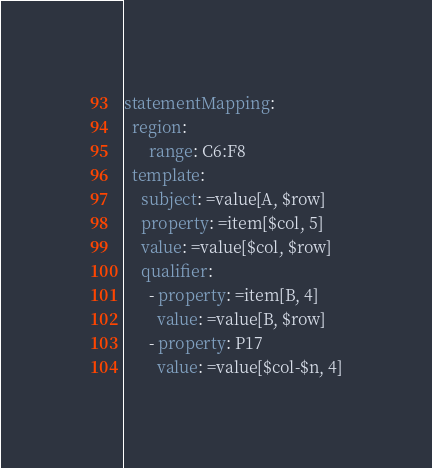<code> <loc_0><loc_0><loc_500><loc_500><_YAML_>statementMapping:
  region:
      range: C6:F8
  template:
    subject: =value[A, $row]
    property: =item[$col, 5]
    value: =value[$col, $row]
    qualifier:
      - property: =item[B, 4]
        value: =value[B, $row]
      - property: P17
        value: =value[$col-$n, 4]
</code> 